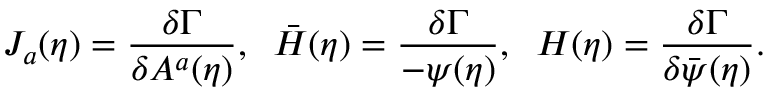<formula> <loc_0><loc_0><loc_500><loc_500>J _ { a } ( \eta ) = \frac { \delta \Gamma } { \delta A ^ { a } ( \eta ) } , \, \bar { H } ( \eta ) = \frac { \delta \Gamma } { - \psi ( \eta ) } , \, H ( \eta ) = \frac { \delta \Gamma } { \delta \bar { \psi } ( \eta ) } .</formula> 